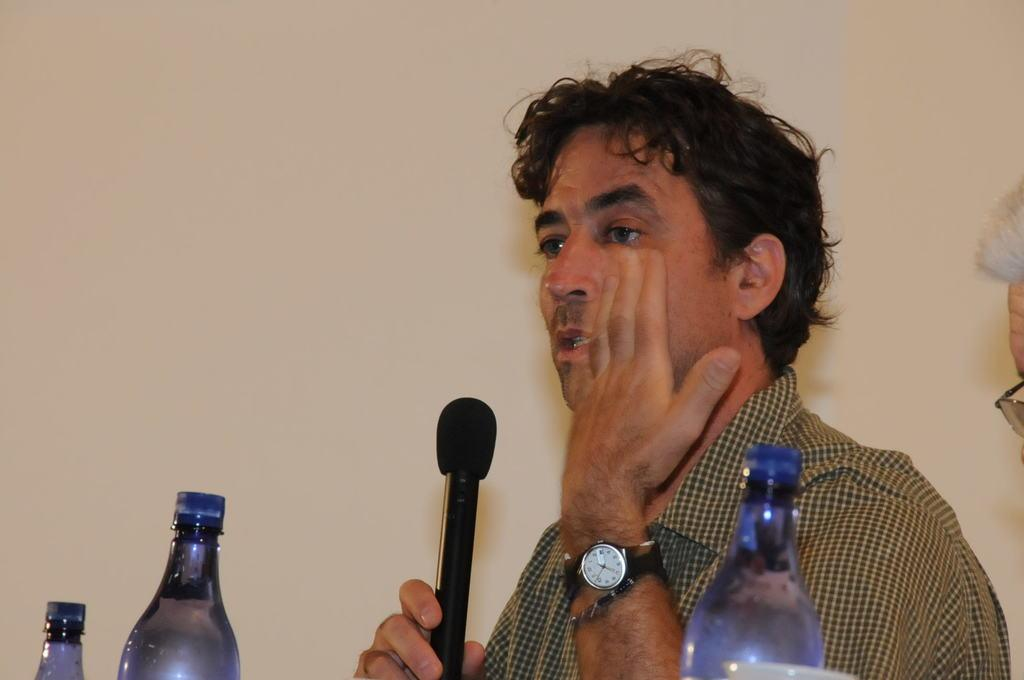What is the person in the image doing? The person is holding a microphone, which suggests they might be speaking or performing. What accessory is the person wearing? The person is wearing a watch. How many bottles are visible in front of the person? There are three bottles in front of the person. Can you describe the other person in the image? There is another person on the right side of the image. What color is the person's nail in the image? There is no mention of a nail or its color in the provided facts, so we cannot answer that question. 